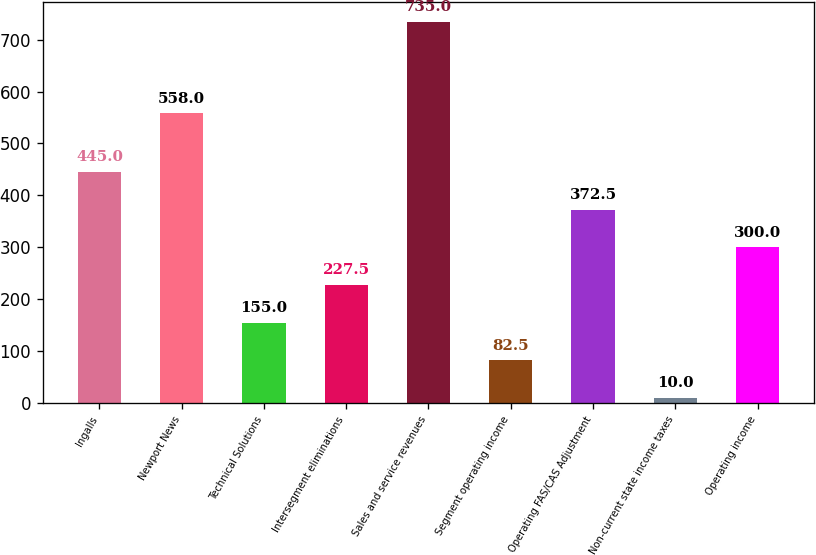Convert chart to OTSL. <chart><loc_0><loc_0><loc_500><loc_500><bar_chart><fcel>Ingalls<fcel>Newport News<fcel>Technical Solutions<fcel>Intersegment eliminations<fcel>Sales and service revenues<fcel>Segment operating income<fcel>Operating FAS/CAS Adjustment<fcel>Non-current state income taxes<fcel>Operating income<nl><fcel>445<fcel>558<fcel>155<fcel>227.5<fcel>735<fcel>82.5<fcel>372.5<fcel>10<fcel>300<nl></chart> 